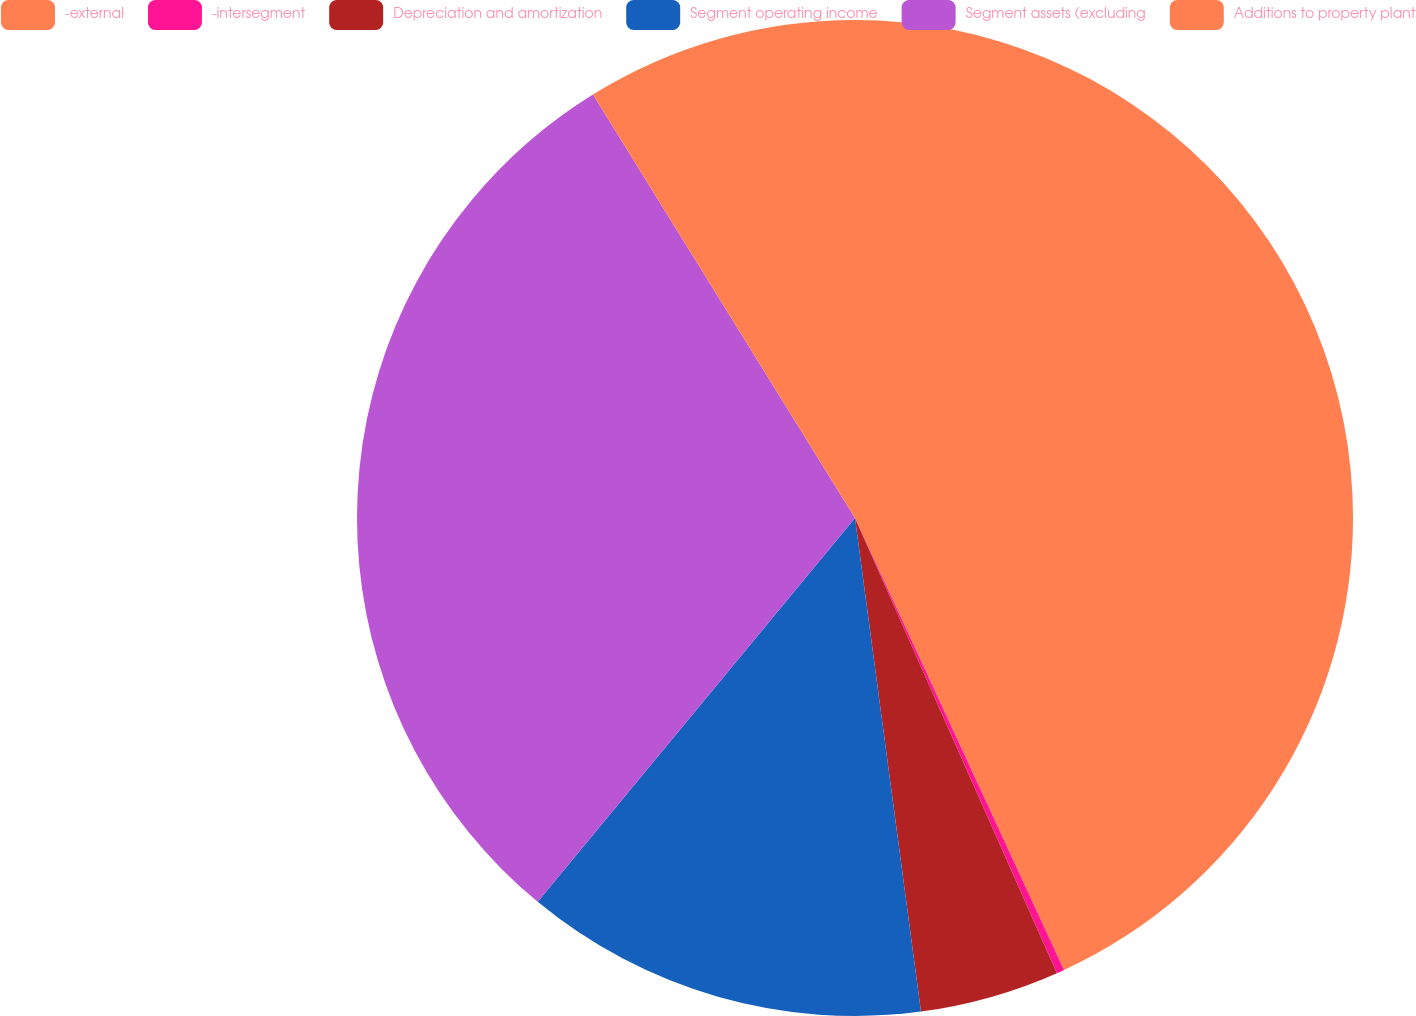Convert chart. <chart><loc_0><loc_0><loc_500><loc_500><pie_chart><fcel>-external<fcel>-intersegment<fcel>Depreciation and amortization<fcel>Segment operating income<fcel>Segment assets (excluding<fcel>Additions to property plant<nl><fcel>43.11%<fcel>0.25%<fcel>4.53%<fcel>13.11%<fcel>30.19%<fcel>8.82%<nl></chart> 